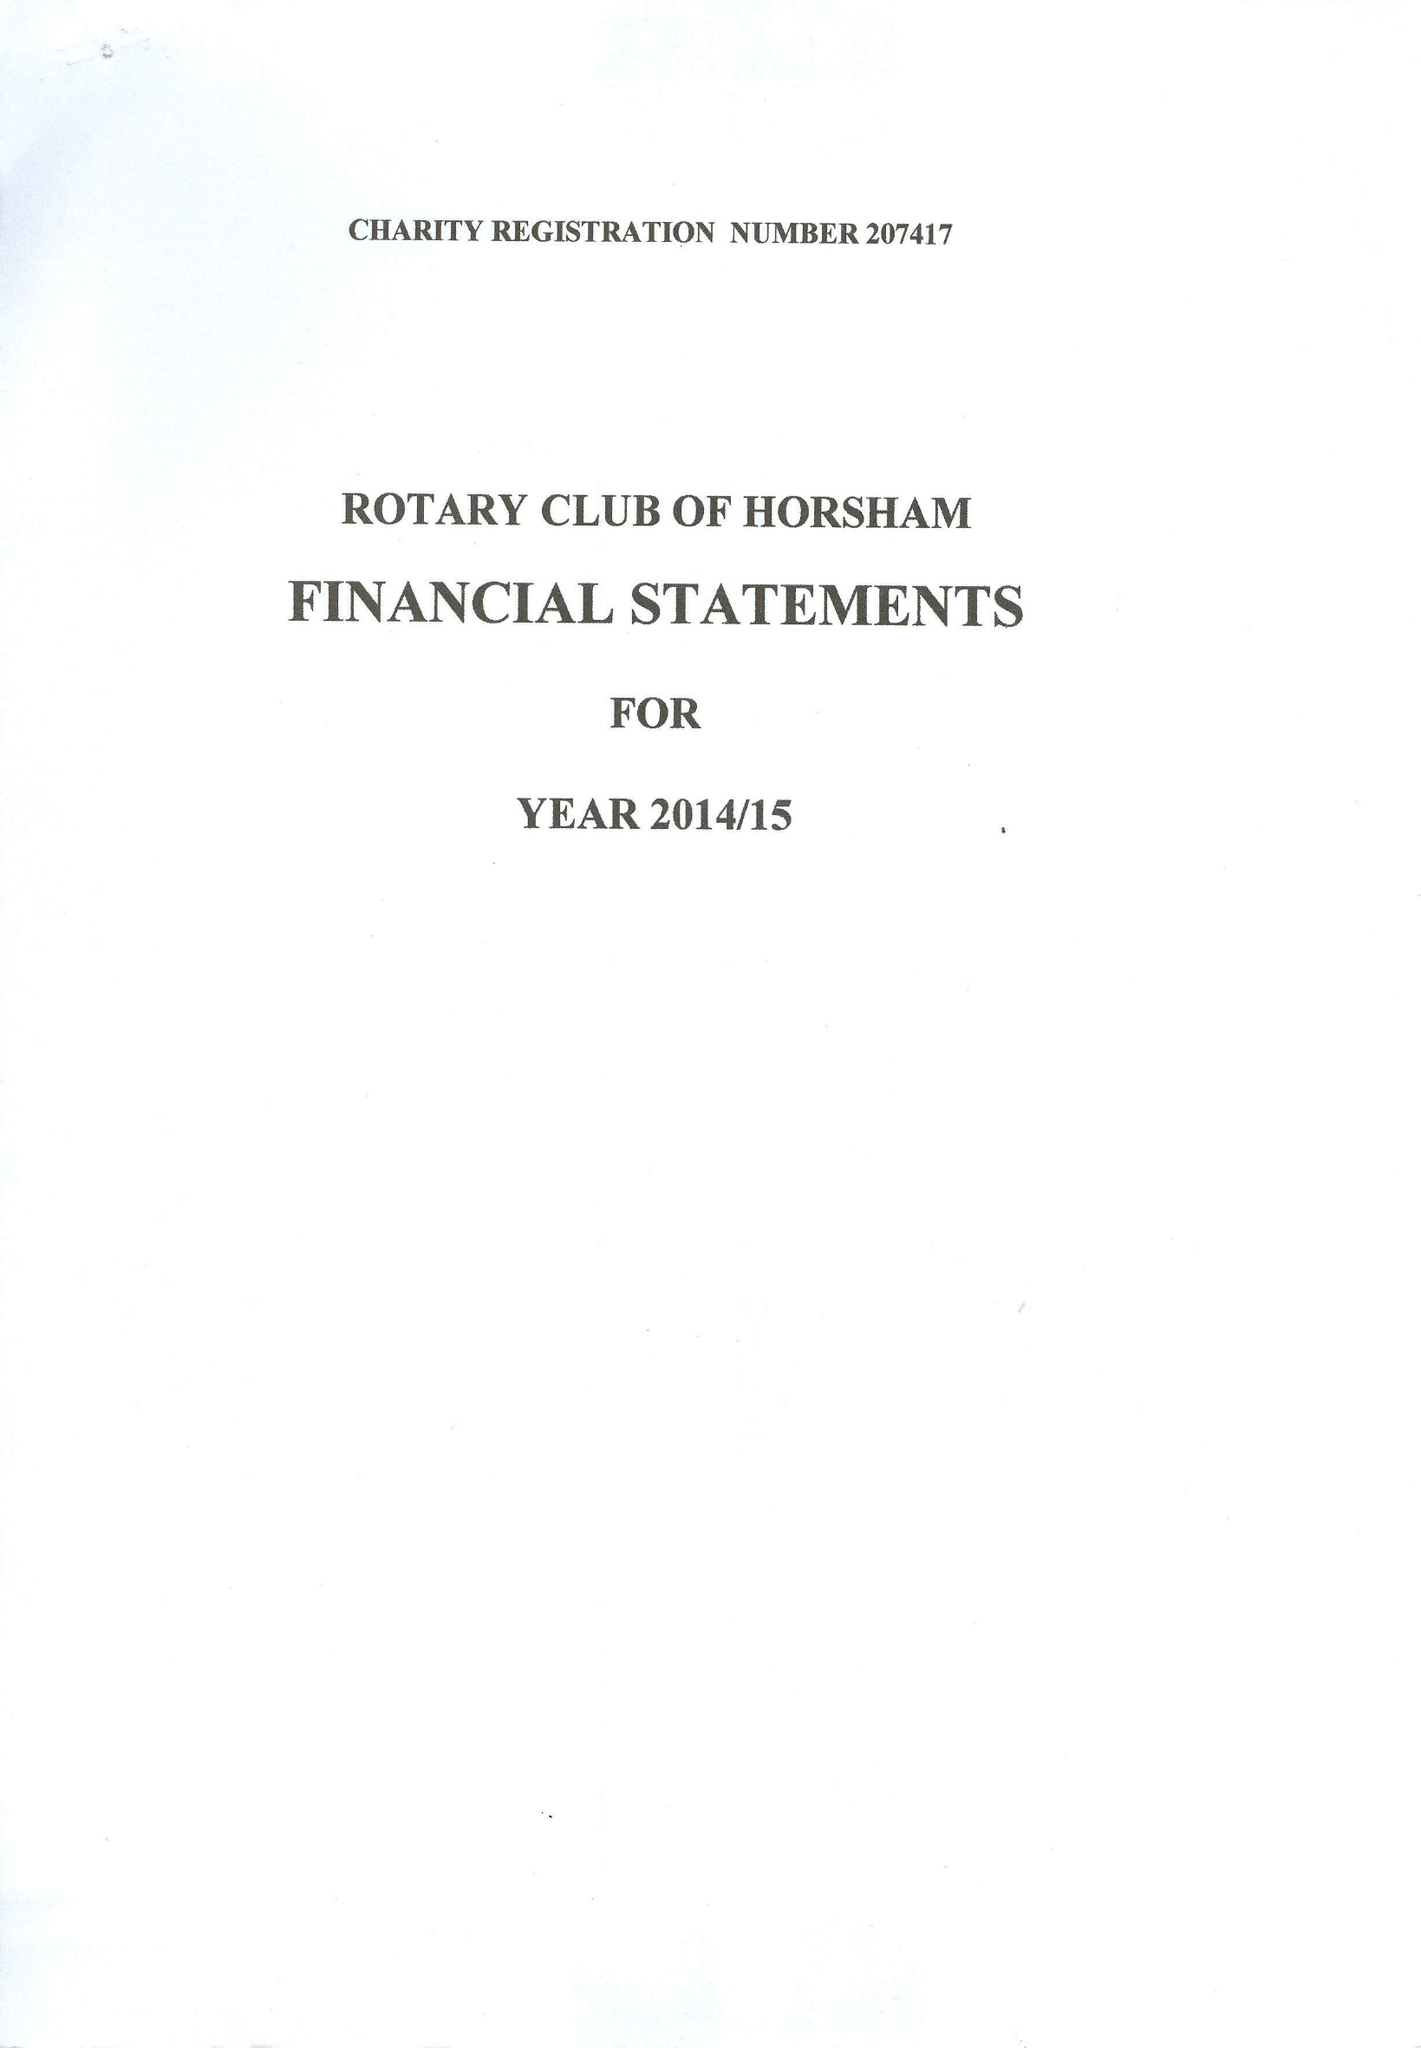What is the value for the address__post_town?
Answer the question using a single word or phrase. DORKING 